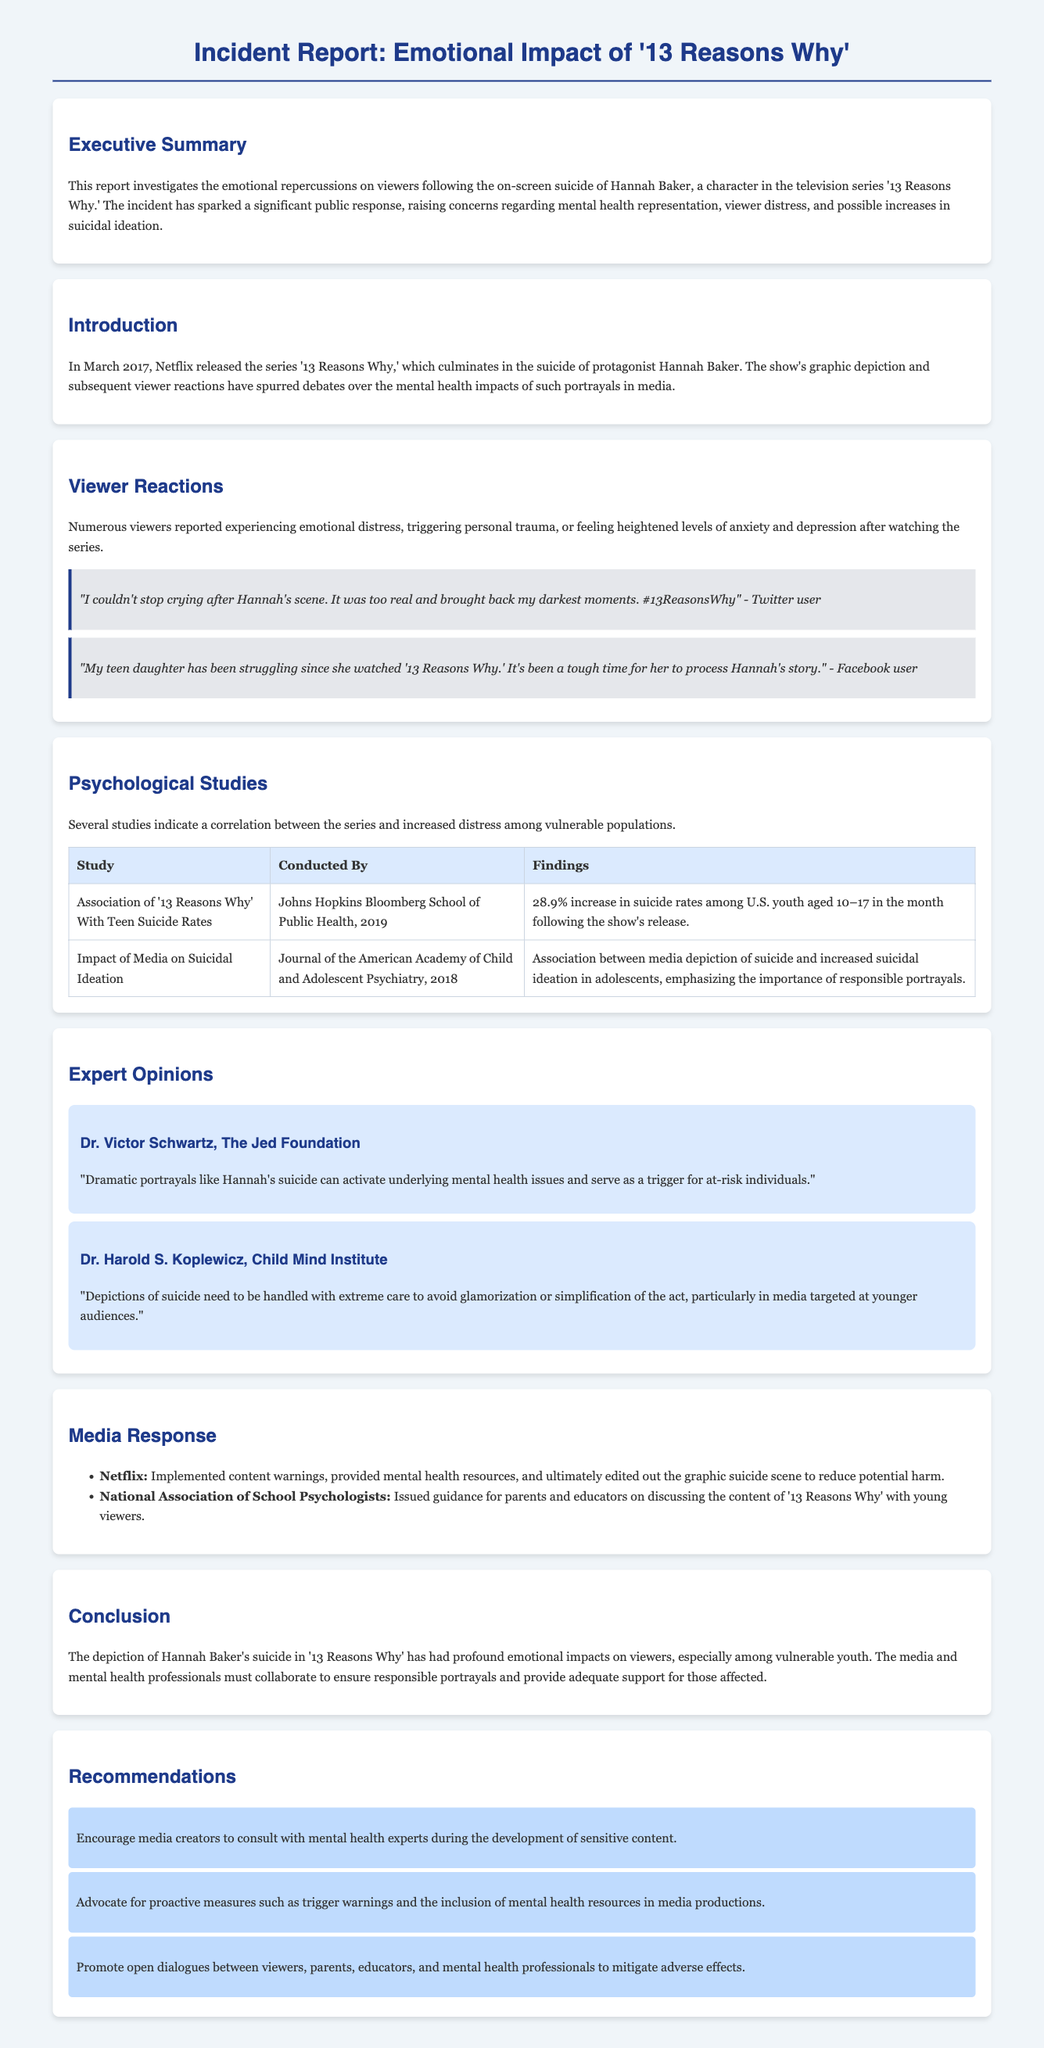What is the title of the TV series discussed in the report? The title of the TV series is explicitly mentioned at the beginning of the document.
Answer: 13 Reasons Why What character's suicide is analyzed in the report? The report focuses on a specific character whose suicide is a major incident in the series, which is mentioned in the Introduction.
Answer: Hannah Baker What percentage increase in suicide rates was reported among U.S. youth after the show's release? The report presents specific findings from studies in the Psychological Studies section, summarizing numerical data.
Answer: 28.9% Who conducted the study on the association of '13 Reasons Why' with teen suicide rates? The document lists authors and institutions for studies mentioned in the Psychological Studies section.
Answer: Johns Hopkins Bloomberg School of Public Health What preventative measure did Netflix implement after the incident? The document outlines specific actions taken by Netflix in the Media Response section.
Answer: Content warnings What is one recommendation made in the report? Several recommendations are explicitly listed in the Recommendations section, which can be used to identify actions suggested.
Answer: Encourage media creators to consult with mental health experts How did viewers respond emotionally after watching '13 Reasons Why'? The report collects viewer reactions in the Viewer Reactions section, indicating their emotional experiences.
Answer: Emotional distress What is a crucial concern raised by experts regarding media portrayals of suicide? Expert opinions in the report highlight specific concerns related to media representation of suicide.
Answer: Glamorization 